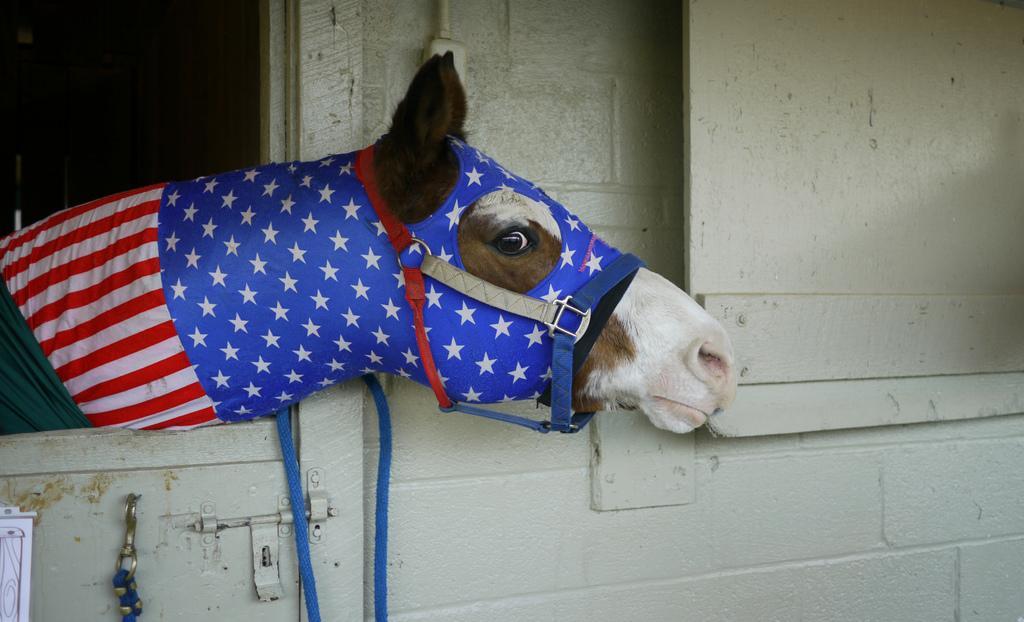How would you summarize this image in a sentence or two? In the image we can see the horse and the wall. 